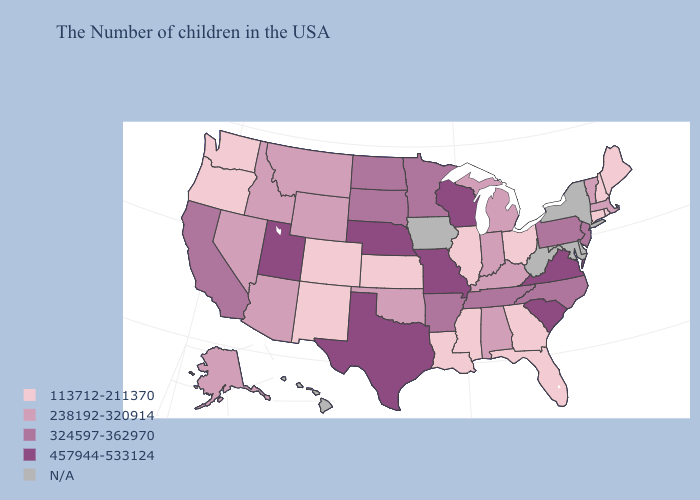Does the map have missing data?
Answer briefly. Yes. What is the value of Utah?
Answer briefly. 457944-533124. What is the highest value in the USA?
Give a very brief answer. 457944-533124. Does Mississippi have the lowest value in the South?
Write a very short answer. Yes. Does the first symbol in the legend represent the smallest category?
Short answer required. Yes. Which states have the lowest value in the USA?
Quick response, please. Maine, Rhode Island, New Hampshire, Connecticut, Ohio, Florida, Georgia, Illinois, Mississippi, Louisiana, Kansas, Colorado, New Mexico, Washington, Oregon. Name the states that have a value in the range N/A?
Quick response, please. New York, Delaware, Maryland, West Virginia, Iowa, Hawaii. What is the lowest value in the USA?
Concise answer only. 113712-211370. Among the states that border California , does Oregon have the highest value?
Write a very short answer. No. What is the value of Arkansas?
Short answer required. 324597-362970. Among the states that border Arizona , which have the lowest value?
Write a very short answer. Colorado, New Mexico. What is the lowest value in the USA?
Be succinct. 113712-211370. Which states have the lowest value in the USA?
Answer briefly. Maine, Rhode Island, New Hampshire, Connecticut, Ohio, Florida, Georgia, Illinois, Mississippi, Louisiana, Kansas, Colorado, New Mexico, Washington, Oregon. Does the first symbol in the legend represent the smallest category?
Quick response, please. Yes. Name the states that have a value in the range 113712-211370?
Answer briefly. Maine, Rhode Island, New Hampshire, Connecticut, Ohio, Florida, Georgia, Illinois, Mississippi, Louisiana, Kansas, Colorado, New Mexico, Washington, Oregon. 